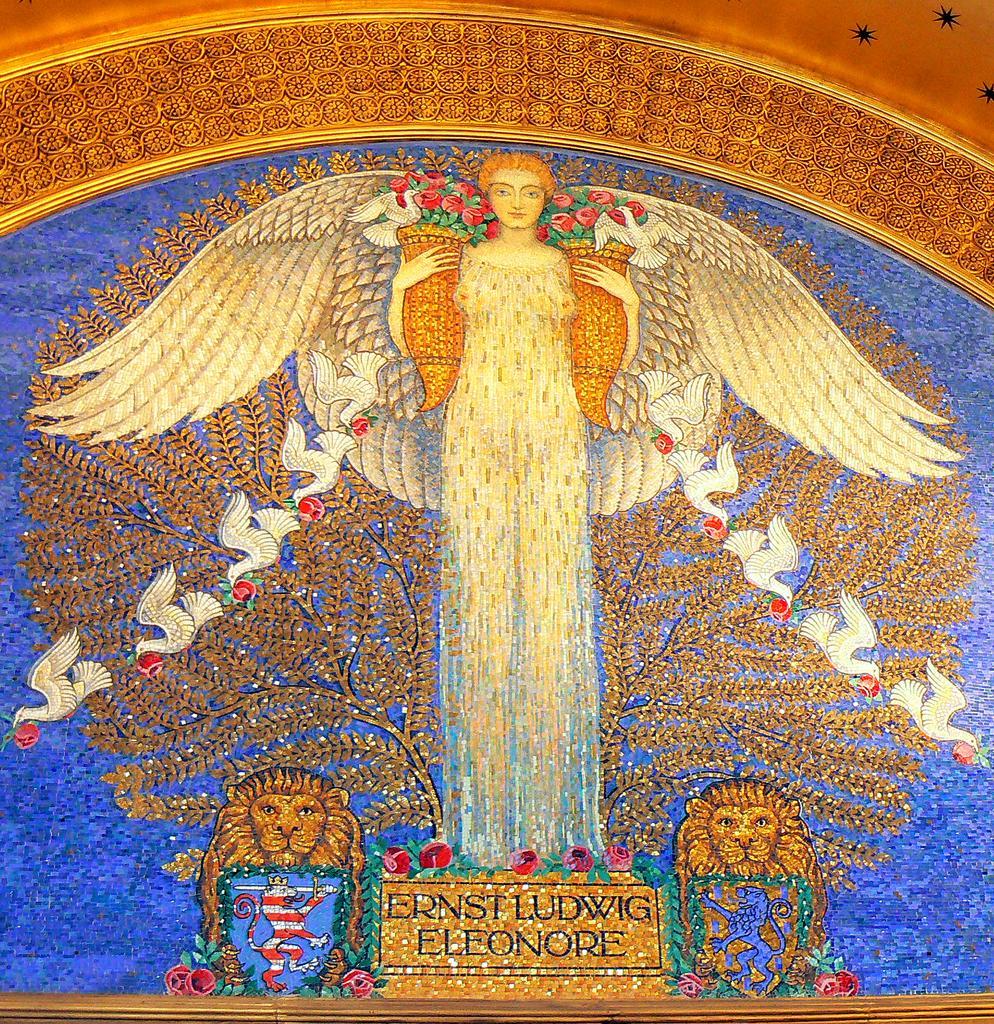Could you give a brief overview of what you see in this image? This is a painting. In this picture we can see a lady is standing and also we can see the animals, birds, tree and text. 